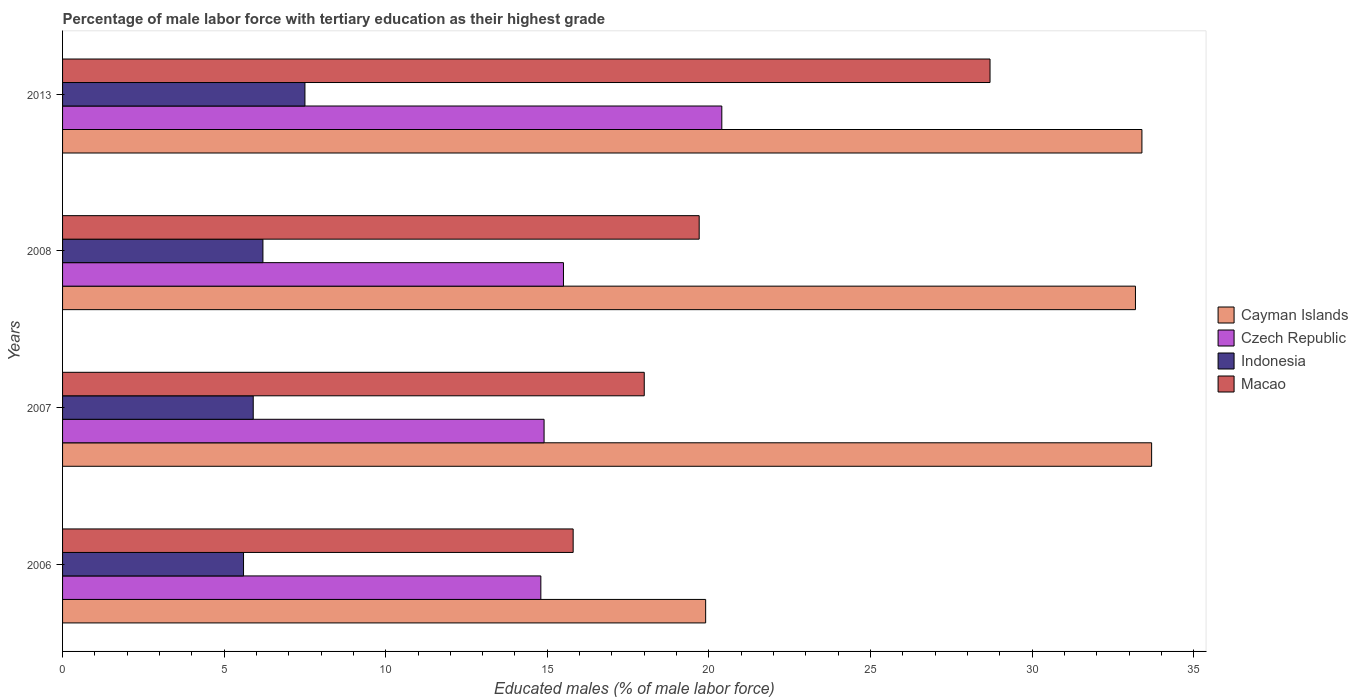Are the number of bars per tick equal to the number of legend labels?
Provide a succinct answer. Yes. How many bars are there on the 4th tick from the top?
Offer a terse response. 4. How many bars are there on the 3rd tick from the bottom?
Provide a succinct answer. 4. What is the label of the 2nd group of bars from the top?
Ensure brevity in your answer.  2008. What is the percentage of male labor force with tertiary education in Macao in 2013?
Your answer should be very brief. 28.7. Across all years, what is the minimum percentage of male labor force with tertiary education in Indonesia?
Ensure brevity in your answer.  5.6. In which year was the percentage of male labor force with tertiary education in Indonesia maximum?
Your answer should be compact. 2013. What is the total percentage of male labor force with tertiary education in Macao in the graph?
Keep it short and to the point. 82.2. What is the difference between the percentage of male labor force with tertiary education in Cayman Islands in 2006 and that in 2007?
Ensure brevity in your answer.  -13.8. What is the difference between the percentage of male labor force with tertiary education in Macao in 2006 and the percentage of male labor force with tertiary education in Czech Republic in 2007?
Your answer should be compact. 0.9. What is the average percentage of male labor force with tertiary education in Czech Republic per year?
Your answer should be compact. 16.4. In the year 2007, what is the difference between the percentage of male labor force with tertiary education in Czech Republic and percentage of male labor force with tertiary education in Macao?
Provide a short and direct response. -3.1. What is the ratio of the percentage of male labor force with tertiary education in Macao in 2007 to that in 2013?
Ensure brevity in your answer.  0.63. What is the difference between the highest and the second highest percentage of male labor force with tertiary education in Cayman Islands?
Provide a succinct answer. 0.3. What is the difference between the highest and the lowest percentage of male labor force with tertiary education in Czech Republic?
Provide a succinct answer. 5.6. In how many years, is the percentage of male labor force with tertiary education in Indonesia greater than the average percentage of male labor force with tertiary education in Indonesia taken over all years?
Your answer should be very brief. 1. Is it the case that in every year, the sum of the percentage of male labor force with tertiary education in Cayman Islands and percentage of male labor force with tertiary education in Macao is greater than the sum of percentage of male labor force with tertiary education in Czech Republic and percentage of male labor force with tertiary education in Indonesia?
Offer a very short reply. No. What does the 2nd bar from the top in 2006 represents?
Your answer should be very brief. Indonesia. What does the 1st bar from the bottom in 2008 represents?
Make the answer very short. Cayman Islands. How many bars are there?
Keep it short and to the point. 16. What is the difference between two consecutive major ticks on the X-axis?
Your answer should be compact. 5. Are the values on the major ticks of X-axis written in scientific E-notation?
Make the answer very short. No. Does the graph contain grids?
Offer a terse response. No. Where does the legend appear in the graph?
Ensure brevity in your answer.  Center right. How many legend labels are there?
Ensure brevity in your answer.  4. What is the title of the graph?
Make the answer very short. Percentage of male labor force with tertiary education as their highest grade. What is the label or title of the X-axis?
Ensure brevity in your answer.  Educated males (% of male labor force). What is the Educated males (% of male labor force) in Cayman Islands in 2006?
Ensure brevity in your answer.  19.9. What is the Educated males (% of male labor force) in Czech Republic in 2006?
Keep it short and to the point. 14.8. What is the Educated males (% of male labor force) in Indonesia in 2006?
Offer a very short reply. 5.6. What is the Educated males (% of male labor force) in Macao in 2006?
Make the answer very short. 15.8. What is the Educated males (% of male labor force) in Cayman Islands in 2007?
Keep it short and to the point. 33.7. What is the Educated males (% of male labor force) in Czech Republic in 2007?
Provide a short and direct response. 14.9. What is the Educated males (% of male labor force) in Indonesia in 2007?
Make the answer very short. 5.9. What is the Educated males (% of male labor force) in Cayman Islands in 2008?
Give a very brief answer. 33.2. What is the Educated males (% of male labor force) of Czech Republic in 2008?
Your answer should be very brief. 15.5. What is the Educated males (% of male labor force) in Indonesia in 2008?
Offer a very short reply. 6.2. What is the Educated males (% of male labor force) of Macao in 2008?
Provide a short and direct response. 19.7. What is the Educated males (% of male labor force) in Cayman Islands in 2013?
Ensure brevity in your answer.  33.4. What is the Educated males (% of male labor force) in Czech Republic in 2013?
Offer a terse response. 20.4. What is the Educated males (% of male labor force) in Indonesia in 2013?
Provide a succinct answer. 7.5. What is the Educated males (% of male labor force) of Macao in 2013?
Provide a succinct answer. 28.7. Across all years, what is the maximum Educated males (% of male labor force) of Cayman Islands?
Provide a succinct answer. 33.7. Across all years, what is the maximum Educated males (% of male labor force) of Czech Republic?
Offer a terse response. 20.4. Across all years, what is the maximum Educated males (% of male labor force) of Indonesia?
Keep it short and to the point. 7.5. Across all years, what is the maximum Educated males (% of male labor force) in Macao?
Provide a short and direct response. 28.7. Across all years, what is the minimum Educated males (% of male labor force) in Cayman Islands?
Offer a terse response. 19.9. Across all years, what is the minimum Educated males (% of male labor force) of Czech Republic?
Your answer should be very brief. 14.8. Across all years, what is the minimum Educated males (% of male labor force) of Indonesia?
Offer a very short reply. 5.6. Across all years, what is the minimum Educated males (% of male labor force) in Macao?
Keep it short and to the point. 15.8. What is the total Educated males (% of male labor force) of Cayman Islands in the graph?
Provide a succinct answer. 120.2. What is the total Educated males (% of male labor force) in Czech Republic in the graph?
Provide a short and direct response. 65.6. What is the total Educated males (% of male labor force) in Indonesia in the graph?
Provide a short and direct response. 25.2. What is the total Educated males (% of male labor force) of Macao in the graph?
Your answer should be compact. 82.2. What is the difference between the Educated males (% of male labor force) of Czech Republic in 2006 and that in 2007?
Keep it short and to the point. -0.1. What is the difference between the Educated males (% of male labor force) of Indonesia in 2006 and that in 2007?
Provide a succinct answer. -0.3. What is the difference between the Educated males (% of male labor force) in Indonesia in 2006 and that in 2008?
Keep it short and to the point. -0.6. What is the difference between the Educated males (% of male labor force) of Macao in 2006 and that in 2008?
Your response must be concise. -3.9. What is the difference between the Educated males (% of male labor force) of Indonesia in 2006 and that in 2013?
Ensure brevity in your answer.  -1.9. What is the difference between the Educated males (% of male labor force) in Cayman Islands in 2007 and that in 2008?
Your answer should be very brief. 0.5. What is the difference between the Educated males (% of male labor force) in Indonesia in 2007 and that in 2008?
Provide a short and direct response. -0.3. What is the difference between the Educated males (% of male labor force) in Macao in 2007 and that in 2008?
Offer a very short reply. -1.7. What is the difference between the Educated males (% of male labor force) of Cayman Islands in 2007 and that in 2013?
Provide a succinct answer. 0.3. What is the difference between the Educated males (% of male labor force) in Czech Republic in 2008 and that in 2013?
Ensure brevity in your answer.  -4.9. What is the difference between the Educated males (% of male labor force) in Indonesia in 2008 and that in 2013?
Give a very brief answer. -1.3. What is the difference between the Educated males (% of male labor force) in Macao in 2008 and that in 2013?
Your answer should be compact. -9. What is the difference between the Educated males (% of male labor force) of Cayman Islands in 2006 and the Educated males (% of male labor force) of Czech Republic in 2007?
Offer a terse response. 5. What is the difference between the Educated males (% of male labor force) of Czech Republic in 2006 and the Educated males (% of male labor force) of Indonesia in 2007?
Your response must be concise. 8.9. What is the difference between the Educated males (% of male labor force) of Cayman Islands in 2006 and the Educated males (% of male labor force) of Indonesia in 2008?
Offer a very short reply. 13.7. What is the difference between the Educated males (% of male labor force) in Czech Republic in 2006 and the Educated males (% of male labor force) in Indonesia in 2008?
Ensure brevity in your answer.  8.6. What is the difference between the Educated males (% of male labor force) in Indonesia in 2006 and the Educated males (% of male labor force) in Macao in 2008?
Keep it short and to the point. -14.1. What is the difference between the Educated males (% of male labor force) in Cayman Islands in 2006 and the Educated males (% of male labor force) in Czech Republic in 2013?
Offer a very short reply. -0.5. What is the difference between the Educated males (% of male labor force) of Czech Republic in 2006 and the Educated males (% of male labor force) of Indonesia in 2013?
Your answer should be compact. 7.3. What is the difference between the Educated males (% of male labor force) in Indonesia in 2006 and the Educated males (% of male labor force) in Macao in 2013?
Offer a terse response. -23.1. What is the difference between the Educated males (% of male labor force) in Cayman Islands in 2007 and the Educated males (% of male labor force) in Macao in 2008?
Provide a short and direct response. 14. What is the difference between the Educated males (% of male labor force) in Czech Republic in 2007 and the Educated males (% of male labor force) in Indonesia in 2008?
Your answer should be compact. 8.7. What is the difference between the Educated males (% of male labor force) of Czech Republic in 2007 and the Educated males (% of male labor force) of Macao in 2008?
Make the answer very short. -4.8. What is the difference between the Educated males (% of male labor force) in Cayman Islands in 2007 and the Educated males (% of male labor force) in Czech Republic in 2013?
Provide a short and direct response. 13.3. What is the difference between the Educated males (% of male labor force) in Cayman Islands in 2007 and the Educated males (% of male labor force) in Indonesia in 2013?
Offer a very short reply. 26.2. What is the difference between the Educated males (% of male labor force) of Cayman Islands in 2007 and the Educated males (% of male labor force) of Macao in 2013?
Ensure brevity in your answer.  5. What is the difference between the Educated males (% of male labor force) in Czech Republic in 2007 and the Educated males (% of male labor force) in Indonesia in 2013?
Make the answer very short. 7.4. What is the difference between the Educated males (% of male labor force) in Indonesia in 2007 and the Educated males (% of male labor force) in Macao in 2013?
Provide a short and direct response. -22.8. What is the difference between the Educated males (% of male labor force) of Cayman Islands in 2008 and the Educated males (% of male labor force) of Czech Republic in 2013?
Your response must be concise. 12.8. What is the difference between the Educated males (% of male labor force) in Cayman Islands in 2008 and the Educated males (% of male labor force) in Indonesia in 2013?
Keep it short and to the point. 25.7. What is the difference between the Educated males (% of male labor force) of Czech Republic in 2008 and the Educated males (% of male labor force) of Macao in 2013?
Ensure brevity in your answer.  -13.2. What is the difference between the Educated males (% of male labor force) in Indonesia in 2008 and the Educated males (% of male labor force) in Macao in 2013?
Your answer should be compact. -22.5. What is the average Educated males (% of male labor force) of Cayman Islands per year?
Your answer should be very brief. 30.05. What is the average Educated males (% of male labor force) of Czech Republic per year?
Keep it short and to the point. 16.4. What is the average Educated males (% of male labor force) of Indonesia per year?
Give a very brief answer. 6.3. What is the average Educated males (% of male labor force) of Macao per year?
Your answer should be very brief. 20.55. In the year 2006, what is the difference between the Educated males (% of male labor force) in Cayman Islands and Educated males (% of male labor force) in Macao?
Your response must be concise. 4.1. In the year 2006, what is the difference between the Educated males (% of male labor force) of Czech Republic and Educated males (% of male labor force) of Indonesia?
Offer a terse response. 9.2. In the year 2007, what is the difference between the Educated males (% of male labor force) in Cayman Islands and Educated males (% of male labor force) in Czech Republic?
Make the answer very short. 18.8. In the year 2007, what is the difference between the Educated males (% of male labor force) in Cayman Islands and Educated males (% of male labor force) in Indonesia?
Provide a succinct answer. 27.8. In the year 2007, what is the difference between the Educated males (% of male labor force) of Cayman Islands and Educated males (% of male labor force) of Macao?
Offer a terse response. 15.7. In the year 2007, what is the difference between the Educated males (% of male labor force) of Czech Republic and Educated males (% of male labor force) of Macao?
Provide a succinct answer. -3.1. In the year 2008, what is the difference between the Educated males (% of male labor force) in Cayman Islands and Educated males (% of male labor force) in Czech Republic?
Provide a short and direct response. 17.7. In the year 2008, what is the difference between the Educated males (% of male labor force) of Cayman Islands and Educated males (% of male labor force) of Indonesia?
Provide a succinct answer. 27. In the year 2008, what is the difference between the Educated males (% of male labor force) in Czech Republic and Educated males (% of male labor force) in Macao?
Your answer should be very brief. -4.2. In the year 2008, what is the difference between the Educated males (% of male labor force) of Indonesia and Educated males (% of male labor force) of Macao?
Your answer should be compact. -13.5. In the year 2013, what is the difference between the Educated males (% of male labor force) of Cayman Islands and Educated males (% of male labor force) of Indonesia?
Provide a short and direct response. 25.9. In the year 2013, what is the difference between the Educated males (% of male labor force) in Indonesia and Educated males (% of male labor force) in Macao?
Give a very brief answer. -21.2. What is the ratio of the Educated males (% of male labor force) in Cayman Islands in 2006 to that in 2007?
Offer a very short reply. 0.59. What is the ratio of the Educated males (% of male labor force) of Indonesia in 2006 to that in 2007?
Provide a short and direct response. 0.95. What is the ratio of the Educated males (% of male labor force) of Macao in 2006 to that in 2007?
Your response must be concise. 0.88. What is the ratio of the Educated males (% of male labor force) of Cayman Islands in 2006 to that in 2008?
Provide a short and direct response. 0.6. What is the ratio of the Educated males (% of male labor force) of Czech Republic in 2006 to that in 2008?
Offer a terse response. 0.95. What is the ratio of the Educated males (% of male labor force) in Indonesia in 2006 to that in 2008?
Offer a terse response. 0.9. What is the ratio of the Educated males (% of male labor force) in Macao in 2006 to that in 2008?
Provide a short and direct response. 0.8. What is the ratio of the Educated males (% of male labor force) of Cayman Islands in 2006 to that in 2013?
Your answer should be very brief. 0.6. What is the ratio of the Educated males (% of male labor force) in Czech Republic in 2006 to that in 2013?
Your answer should be compact. 0.73. What is the ratio of the Educated males (% of male labor force) of Indonesia in 2006 to that in 2013?
Provide a short and direct response. 0.75. What is the ratio of the Educated males (% of male labor force) in Macao in 2006 to that in 2013?
Give a very brief answer. 0.55. What is the ratio of the Educated males (% of male labor force) in Cayman Islands in 2007 to that in 2008?
Make the answer very short. 1.02. What is the ratio of the Educated males (% of male labor force) in Czech Republic in 2007 to that in 2008?
Provide a short and direct response. 0.96. What is the ratio of the Educated males (% of male labor force) of Indonesia in 2007 to that in 2008?
Your response must be concise. 0.95. What is the ratio of the Educated males (% of male labor force) of Macao in 2007 to that in 2008?
Offer a terse response. 0.91. What is the ratio of the Educated males (% of male labor force) in Cayman Islands in 2007 to that in 2013?
Offer a terse response. 1.01. What is the ratio of the Educated males (% of male labor force) in Czech Republic in 2007 to that in 2013?
Your answer should be very brief. 0.73. What is the ratio of the Educated males (% of male labor force) in Indonesia in 2007 to that in 2013?
Make the answer very short. 0.79. What is the ratio of the Educated males (% of male labor force) in Macao in 2007 to that in 2013?
Ensure brevity in your answer.  0.63. What is the ratio of the Educated males (% of male labor force) in Czech Republic in 2008 to that in 2013?
Provide a short and direct response. 0.76. What is the ratio of the Educated males (% of male labor force) in Indonesia in 2008 to that in 2013?
Your answer should be compact. 0.83. What is the ratio of the Educated males (% of male labor force) of Macao in 2008 to that in 2013?
Offer a terse response. 0.69. What is the difference between the highest and the second highest Educated males (% of male labor force) of Cayman Islands?
Keep it short and to the point. 0.3. What is the difference between the highest and the second highest Educated males (% of male labor force) in Czech Republic?
Your answer should be compact. 4.9. What is the difference between the highest and the second highest Educated males (% of male labor force) of Macao?
Ensure brevity in your answer.  9. What is the difference between the highest and the lowest Educated males (% of male labor force) in Cayman Islands?
Make the answer very short. 13.8. What is the difference between the highest and the lowest Educated males (% of male labor force) in Macao?
Ensure brevity in your answer.  12.9. 